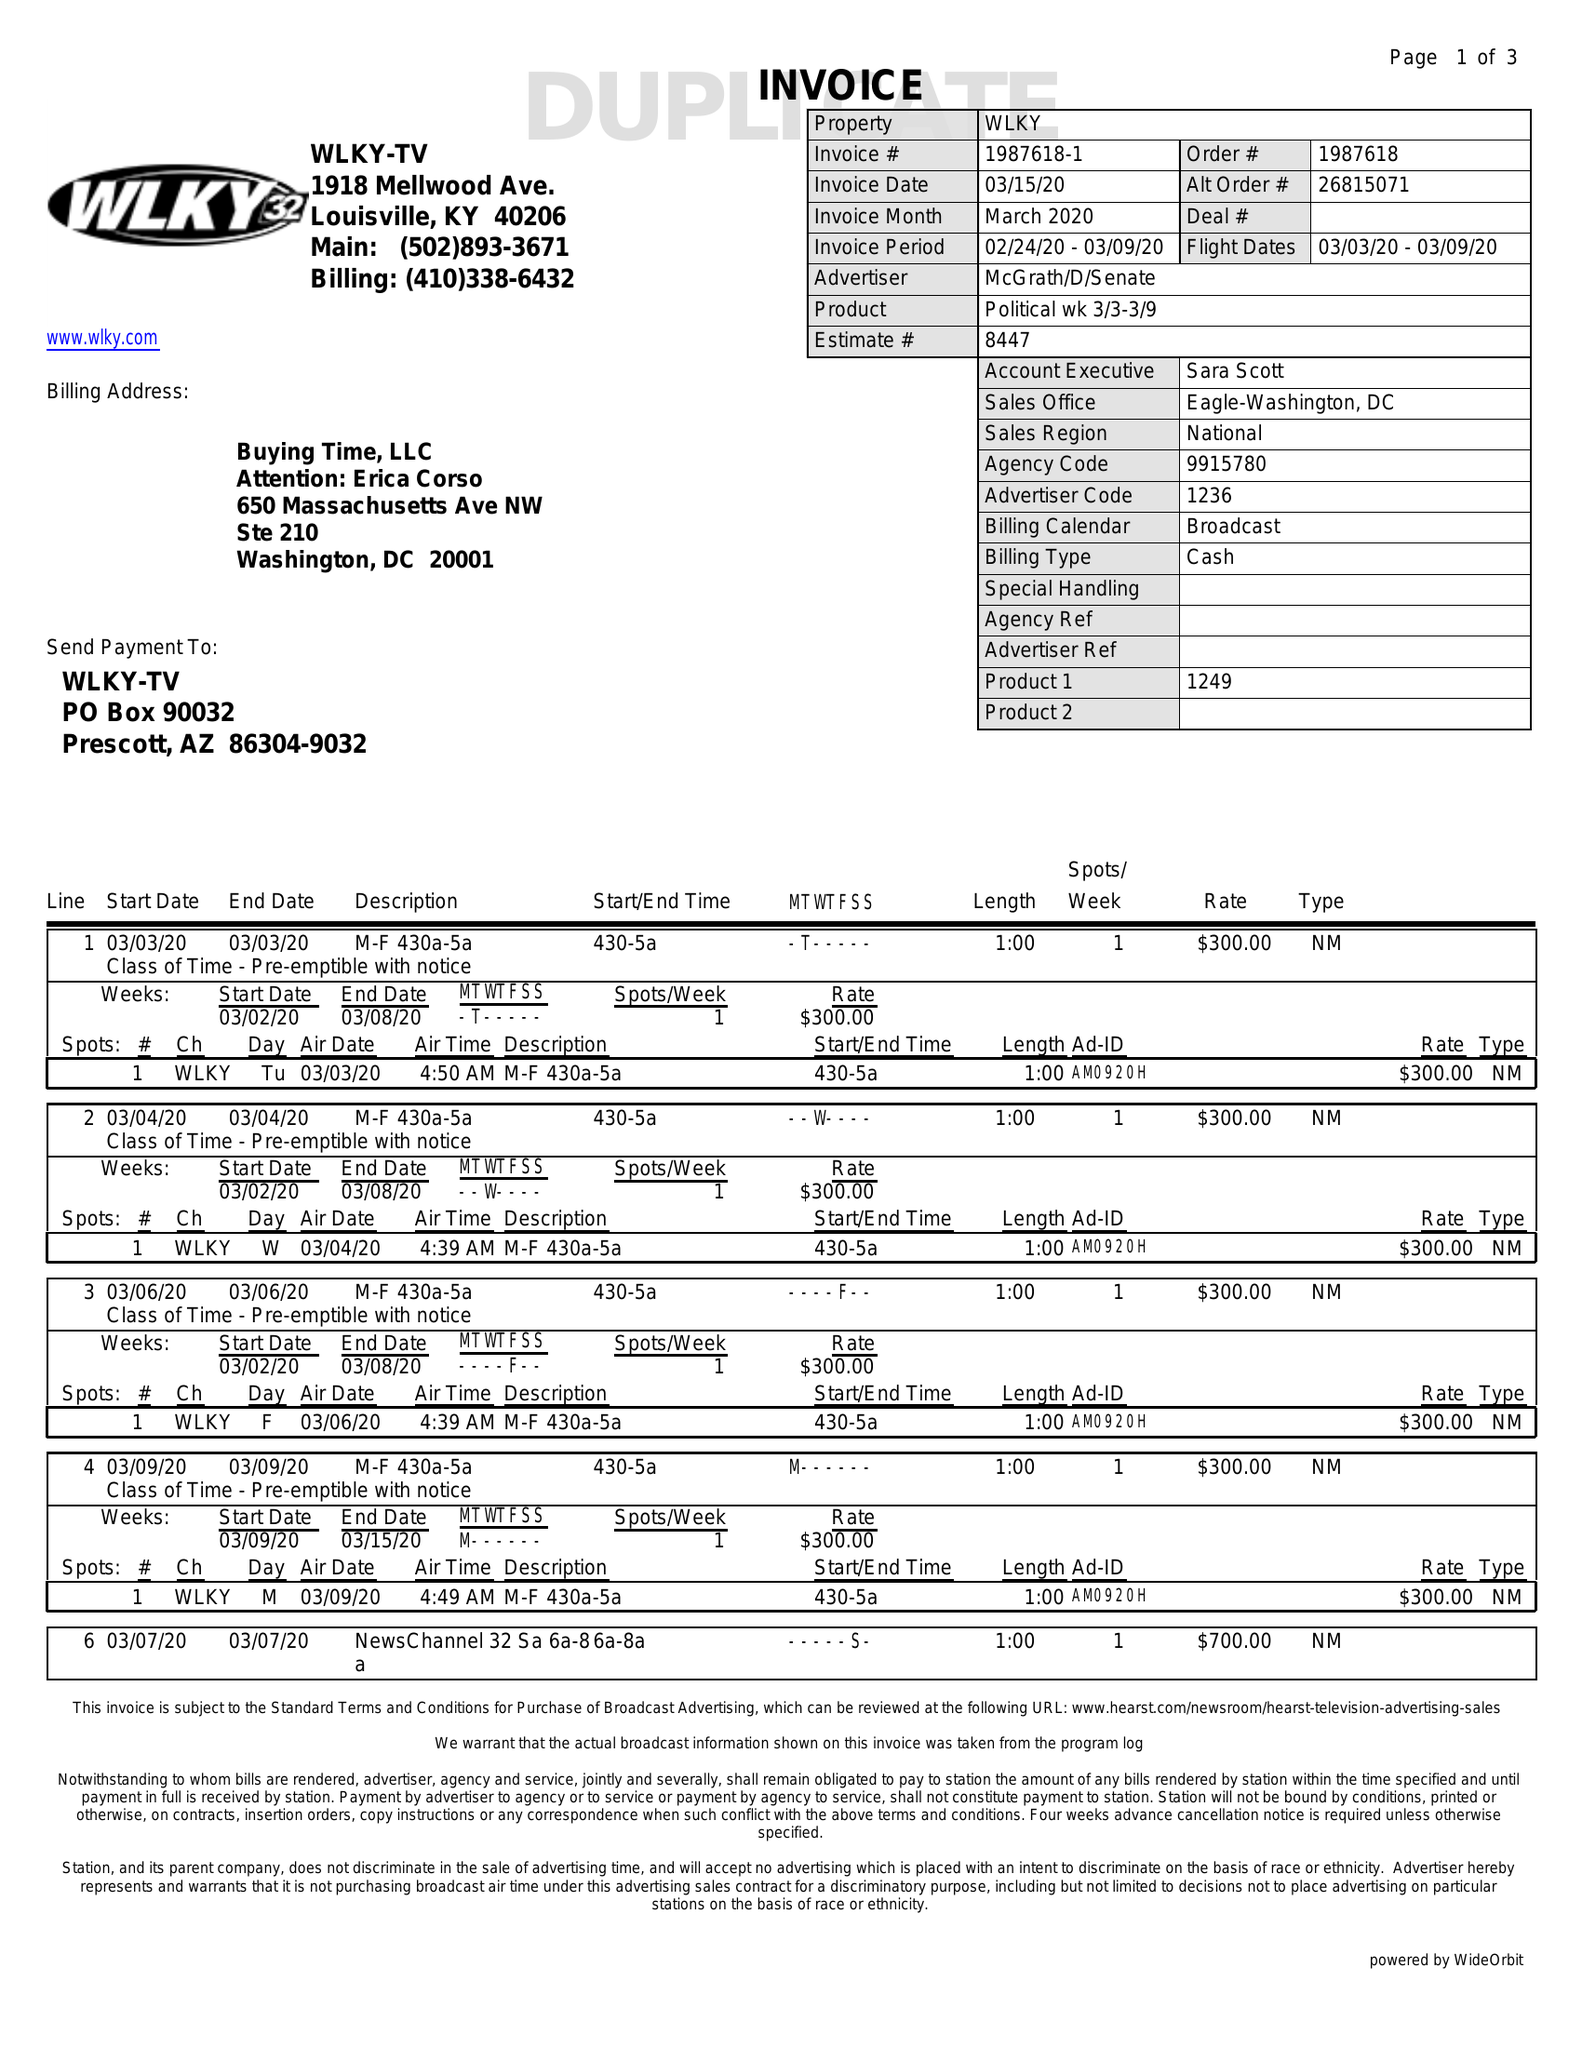What is the value for the contract_num?
Answer the question using a single word or phrase. 1987618 